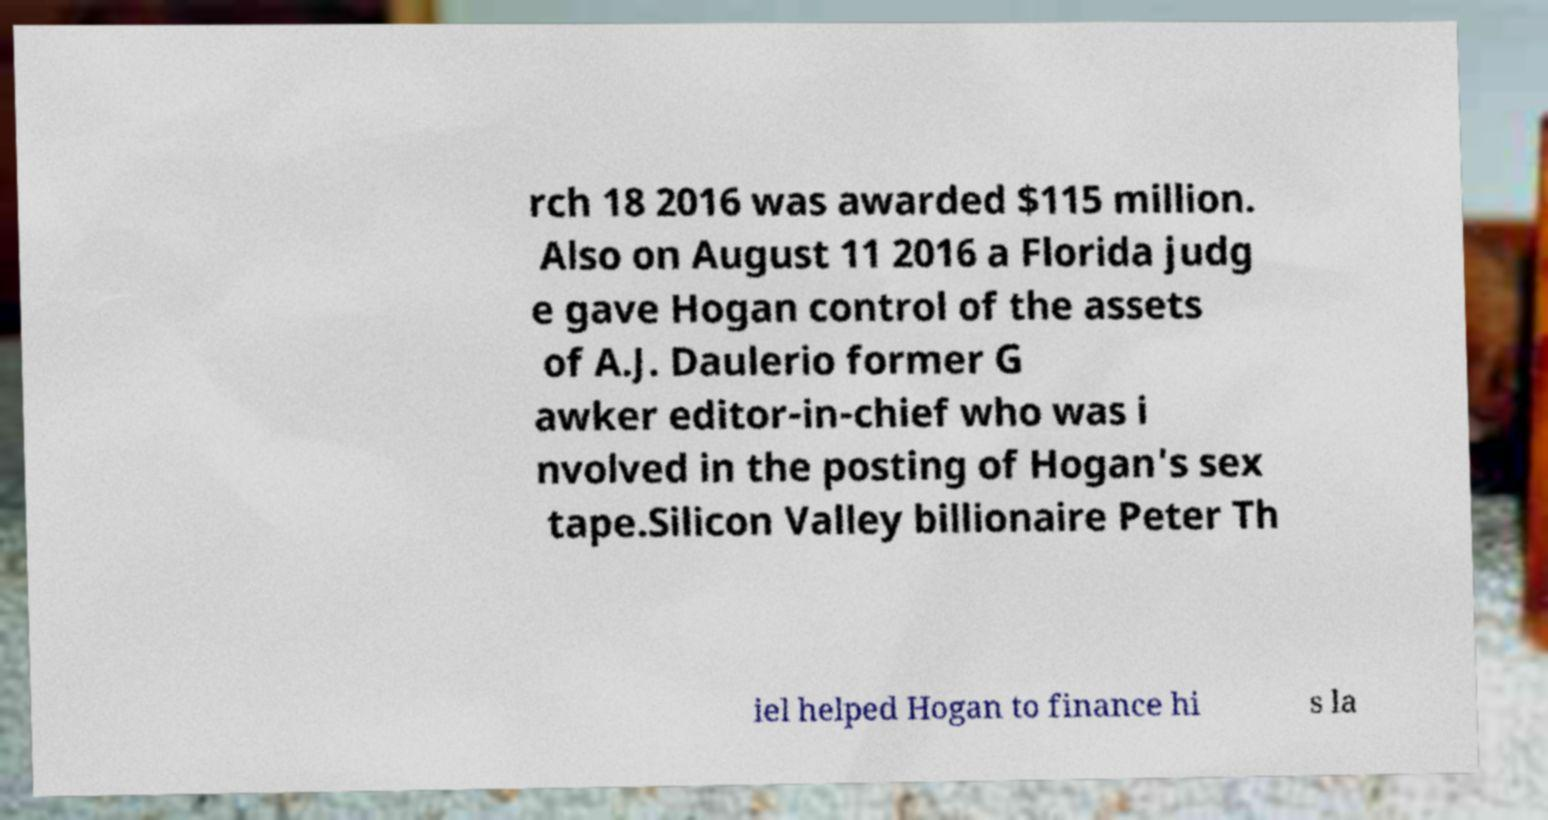Please identify and transcribe the text found in this image. rch 18 2016 was awarded $115 million. Also on August 11 2016 a Florida judg e gave Hogan control of the assets of A.J. Daulerio former G awker editor-in-chief who was i nvolved in the posting of Hogan's sex tape.Silicon Valley billionaire Peter Th iel helped Hogan to finance hi s la 